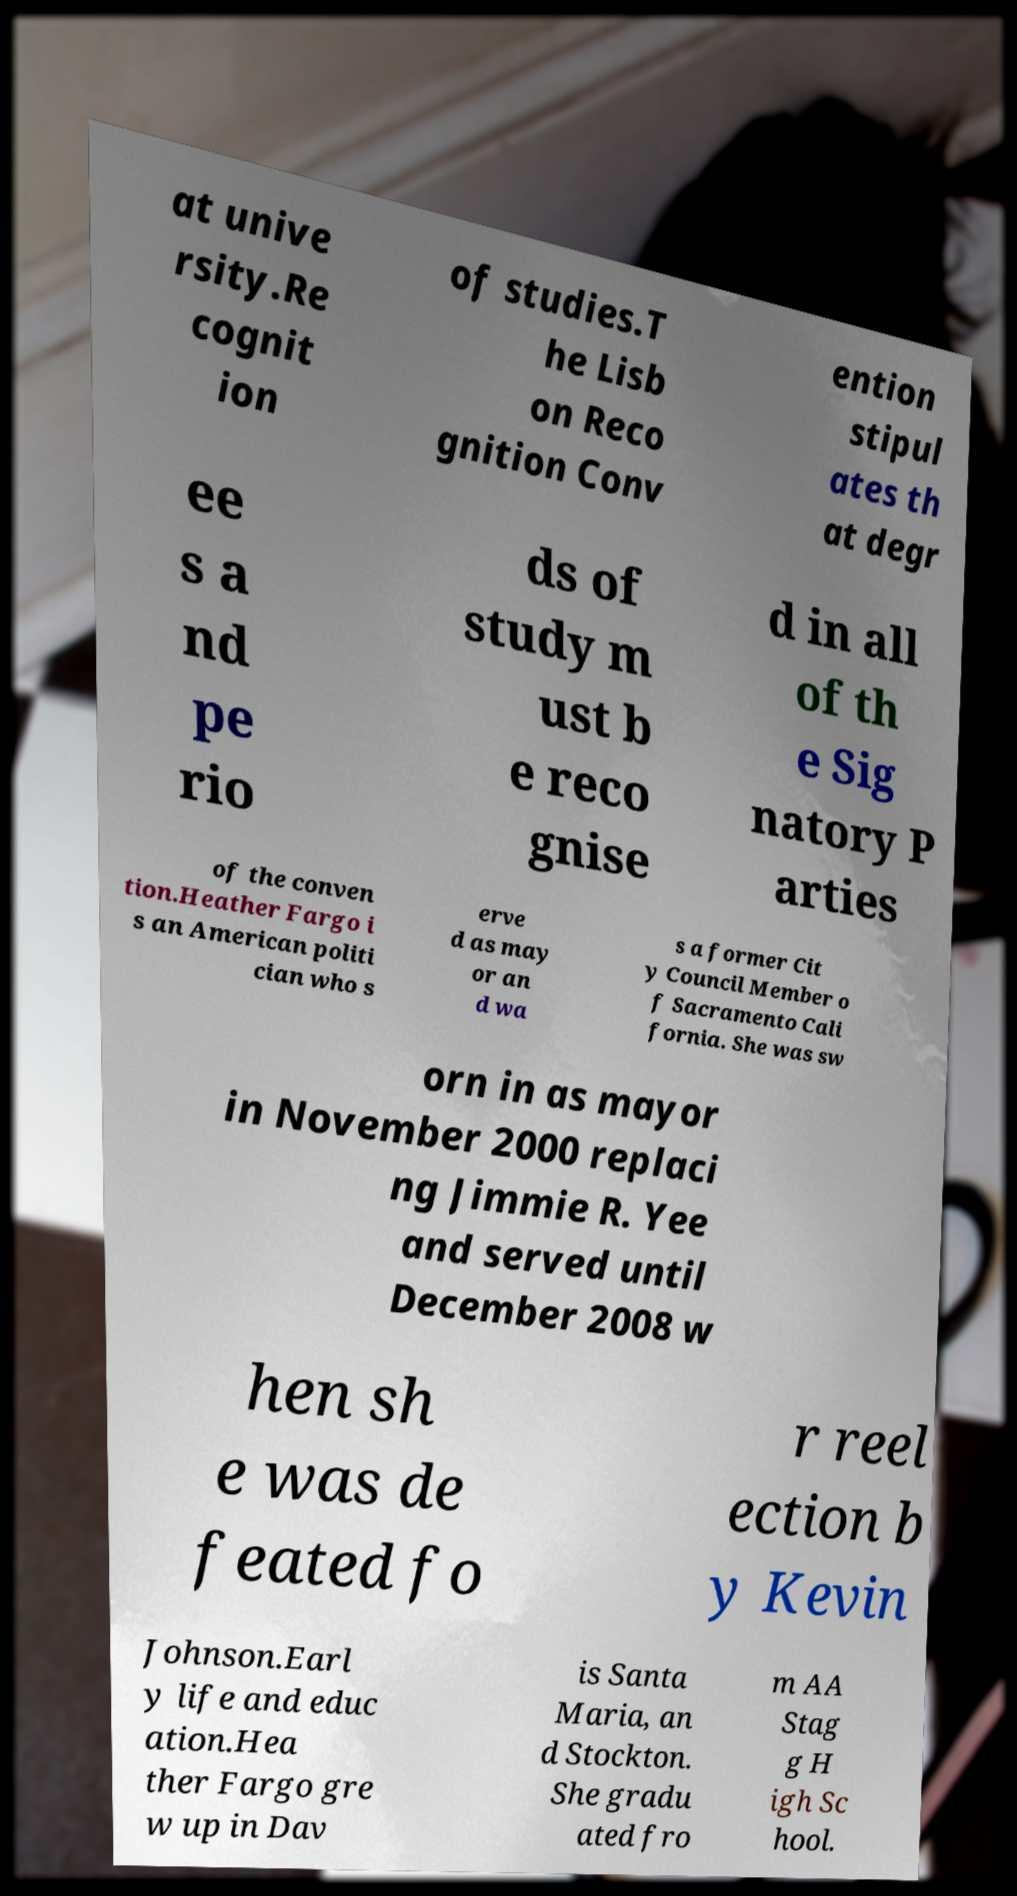Can you accurately transcribe the text from the provided image for me? at unive rsity.Re cognit ion of studies.T he Lisb on Reco gnition Conv ention stipul ates th at degr ee s a nd pe rio ds of study m ust b e reco gnise d in all of th e Sig natory P arties of the conven tion.Heather Fargo i s an American politi cian who s erve d as may or an d wa s a former Cit y Council Member o f Sacramento Cali fornia. She was sw orn in as mayor in November 2000 replaci ng Jimmie R. Yee and served until December 2008 w hen sh e was de feated fo r reel ection b y Kevin Johnson.Earl y life and educ ation.Hea ther Fargo gre w up in Dav is Santa Maria, an d Stockton. She gradu ated fro m AA Stag g H igh Sc hool. 